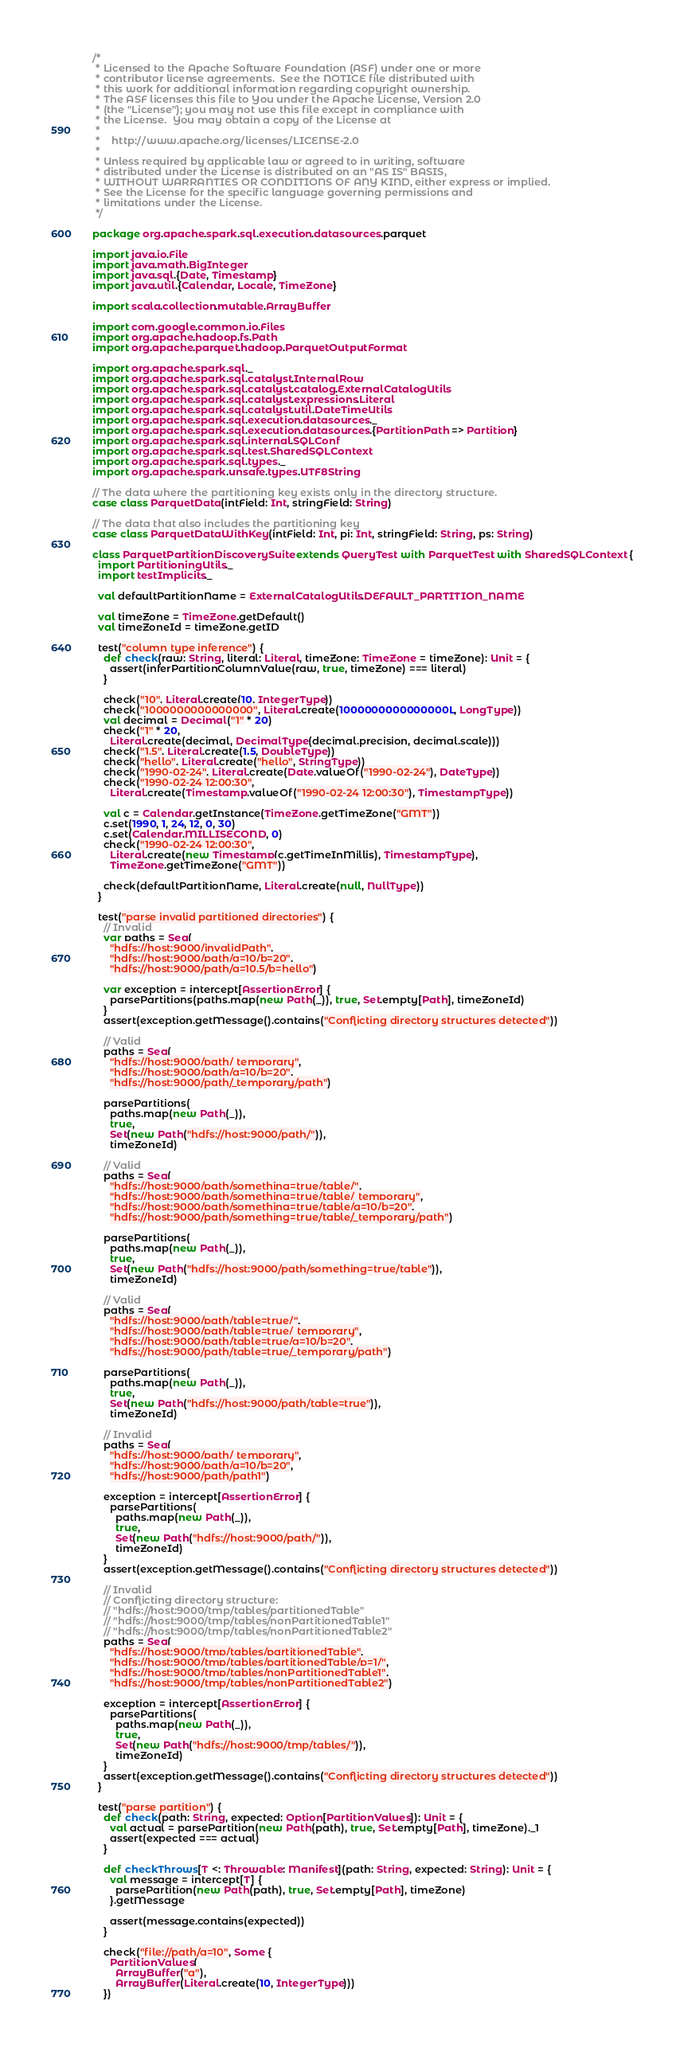Convert code to text. <code><loc_0><loc_0><loc_500><loc_500><_Scala_>/*
 * Licensed to the Apache Software Foundation (ASF) under one or more
 * contributor license agreements.  See the NOTICE file distributed with
 * this work for additional information regarding copyright ownership.
 * The ASF licenses this file to You under the Apache License, Version 2.0
 * (the "License"); you may not use this file except in compliance with
 * the License.  You may obtain a copy of the License at
 *
 *    http://www.apache.org/licenses/LICENSE-2.0
 *
 * Unless required by applicable law or agreed to in writing, software
 * distributed under the License is distributed on an "AS IS" BASIS,
 * WITHOUT WARRANTIES OR CONDITIONS OF ANY KIND, either express or implied.
 * See the License for the specific language governing permissions and
 * limitations under the License.
 */

package org.apache.spark.sql.execution.datasources.parquet

import java.io.File
import java.math.BigInteger
import java.sql.{Date, Timestamp}
import java.util.{Calendar, Locale, TimeZone}

import scala.collection.mutable.ArrayBuffer

import com.google.common.io.Files
import org.apache.hadoop.fs.Path
import org.apache.parquet.hadoop.ParquetOutputFormat

import org.apache.spark.sql._
import org.apache.spark.sql.catalyst.InternalRow
import org.apache.spark.sql.catalyst.catalog.ExternalCatalogUtils
import org.apache.spark.sql.catalyst.expressions.Literal
import org.apache.spark.sql.catalyst.util.DateTimeUtils
import org.apache.spark.sql.execution.datasources._
import org.apache.spark.sql.execution.datasources.{PartitionPath => Partition}
import org.apache.spark.sql.internal.SQLConf
import org.apache.spark.sql.test.SharedSQLContext
import org.apache.spark.sql.types._
import org.apache.spark.unsafe.types.UTF8String

// The data where the partitioning key exists only in the directory structure.
case class ParquetData(intField: Int, stringField: String)

// The data that also includes the partitioning key
case class ParquetDataWithKey(intField: Int, pi: Int, stringField: String, ps: String)

class ParquetPartitionDiscoverySuite extends QueryTest with ParquetTest with SharedSQLContext {
  import PartitioningUtils._
  import testImplicits._

  val defaultPartitionName = ExternalCatalogUtils.DEFAULT_PARTITION_NAME

  val timeZone = TimeZone.getDefault()
  val timeZoneId = timeZone.getID

  test("column type inference") {
    def check(raw: String, literal: Literal, timeZone: TimeZone = timeZone): Unit = {
      assert(inferPartitionColumnValue(raw, true, timeZone) === literal)
    }

    check("10", Literal.create(10, IntegerType))
    check("1000000000000000", Literal.create(1000000000000000L, LongType))
    val decimal = Decimal("1" * 20)
    check("1" * 20,
      Literal.create(decimal, DecimalType(decimal.precision, decimal.scale)))
    check("1.5", Literal.create(1.5, DoubleType))
    check("hello", Literal.create("hello", StringType))
    check("1990-02-24", Literal.create(Date.valueOf("1990-02-24"), DateType))
    check("1990-02-24 12:00:30",
      Literal.create(Timestamp.valueOf("1990-02-24 12:00:30"), TimestampType))

    val c = Calendar.getInstance(TimeZone.getTimeZone("GMT"))
    c.set(1990, 1, 24, 12, 0, 30)
    c.set(Calendar.MILLISECOND, 0)
    check("1990-02-24 12:00:30",
      Literal.create(new Timestamp(c.getTimeInMillis), TimestampType),
      TimeZone.getTimeZone("GMT"))

    check(defaultPartitionName, Literal.create(null, NullType))
  }

  test("parse invalid partitioned directories") {
    // Invalid
    var paths = Seq(
      "hdfs://host:9000/invalidPath",
      "hdfs://host:9000/path/a=10/b=20",
      "hdfs://host:9000/path/a=10.5/b=hello")

    var exception = intercept[AssertionError] {
      parsePartitions(paths.map(new Path(_)), true, Set.empty[Path], timeZoneId)
    }
    assert(exception.getMessage().contains("Conflicting directory structures detected"))

    // Valid
    paths = Seq(
      "hdfs://host:9000/path/_temporary",
      "hdfs://host:9000/path/a=10/b=20",
      "hdfs://host:9000/path/_temporary/path")

    parsePartitions(
      paths.map(new Path(_)),
      true,
      Set(new Path("hdfs://host:9000/path/")),
      timeZoneId)

    // Valid
    paths = Seq(
      "hdfs://host:9000/path/something=true/table/",
      "hdfs://host:9000/path/something=true/table/_temporary",
      "hdfs://host:9000/path/something=true/table/a=10/b=20",
      "hdfs://host:9000/path/something=true/table/_temporary/path")

    parsePartitions(
      paths.map(new Path(_)),
      true,
      Set(new Path("hdfs://host:9000/path/something=true/table")),
      timeZoneId)

    // Valid
    paths = Seq(
      "hdfs://host:9000/path/table=true/",
      "hdfs://host:9000/path/table=true/_temporary",
      "hdfs://host:9000/path/table=true/a=10/b=20",
      "hdfs://host:9000/path/table=true/_temporary/path")

    parsePartitions(
      paths.map(new Path(_)),
      true,
      Set(new Path("hdfs://host:9000/path/table=true")),
      timeZoneId)

    // Invalid
    paths = Seq(
      "hdfs://host:9000/path/_temporary",
      "hdfs://host:9000/path/a=10/b=20",
      "hdfs://host:9000/path/path1")

    exception = intercept[AssertionError] {
      parsePartitions(
        paths.map(new Path(_)),
        true,
        Set(new Path("hdfs://host:9000/path/")),
        timeZoneId)
    }
    assert(exception.getMessage().contains("Conflicting directory structures detected"))

    // Invalid
    // Conflicting directory structure:
    // "hdfs://host:9000/tmp/tables/partitionedTable"
    // "hdfs://host:9000/tmp/tables/nonPartitionedTable1"
    // "hdfs://host:9000/tmp/tables/nonPartitionedTable2"
    paths = Seq(
      "hdfs://host:9000/tmp/tables/partitionedTable",
      "hdfs://host:9000/tmp/tables/partitionedTable/p=1/",
      "hdfs://host:9000/tmp/tables/nonPartitionedTable1",
      "hdfs://host:9000/tmp/tables/nonPartitionedTable2")

    exception = intercept[AssertionError] {
      parsePartitions(
        paths.map(new Path(_)),
        true,
        Set(new Path("hdfs://host:9000/tmp/tables/")),
        timeZoneId)
    }
    assert(exception.getMessage().contains("Conflicting directory structures detected"))
  }

  test("parse partition") {
    def check(path: String, expected: Option[PartitionValues]): Unit = {
      val actual = parsePartition(new Path(path), true, Set.empty[Path], timeZone)._1
      assert(expected === actual)
    }

    def checkThrows[T <: Throwable: Manifest](path: String, expected: String): Unit = {
      val message = intercept[T] {
        parsePartition(new Path(path), true, Set.empty[Path], timeZone)
      }.getMessage

      assert(message.contains(expected))
    }

    check("file://path/a=10", Some {
      PartitionValues(
        ArrayBuffer("a"),
        ArrayBuffer(Literal.create(10, IntegerType)))
    })
</code> 